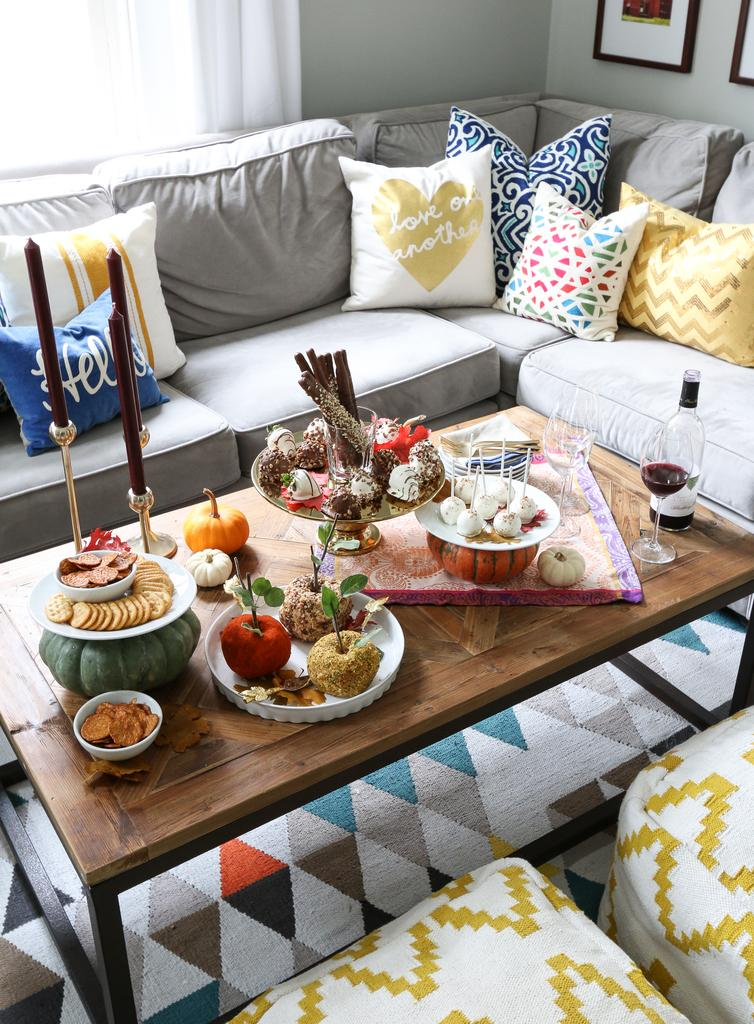What type of furniture is present in the image? There is a table in the image. What is placed on the table? There are food items on the table. What type of seating is available around the table? There are sofas around the table. What type of cushioning is provided on the sofas? There are pillows on the sofas. What type of worm can be seen crawling on the food items in the image? There is no worm present in the image; it only features food items on a table with sofas and pillows around it. 